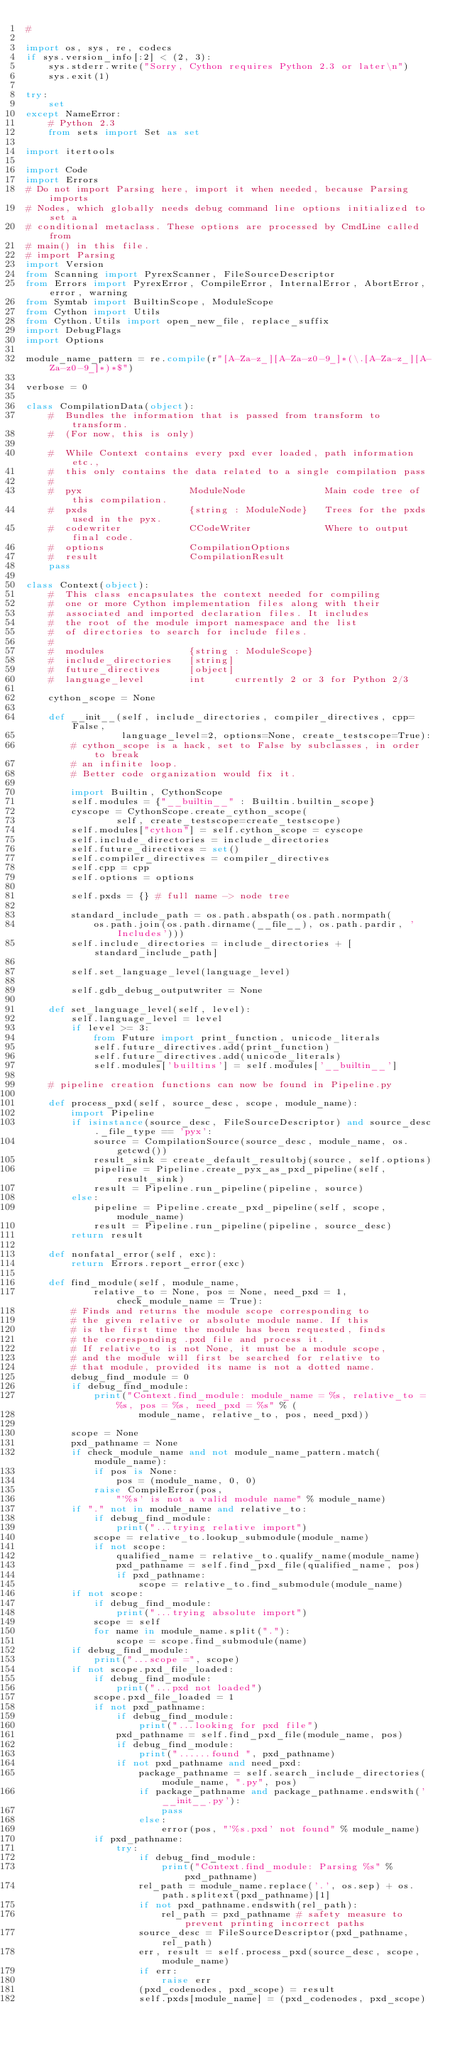<code> <loc_0><loc_0><loc_500><loc_500><_Python_>#

import os, sys, re, codecs
if sys.version_info[:2] < (2, 3):
    sys.stderr.write("Sorry, Cython requires Python 2.3 or later\n")
    sys.exit(1)

try:
    set
except NameError:
    # Python 2.3
    from sets import Set as set

import itertools

import Code
import Errors
# Do not import Parsing here, import it when needed, because Parsing imports
# Nodes, which globally needs debug command line options initialized to set a
# conditional metaclass. These options are processed by CmdLine called from
# main() in this file.
# import Parsing
import Version
from Scanning import PyrexScanner, FileSourceDescriptor
from Errors import PyrexError, CompileError, InternalError, AbortError, error, warning
from Symtab import BuiltinScope, ModuleScope
from Cython import Utils
from Cython.Utils import open_new_file, replace_suffix
import DebugFlags
import Options

module_name_pattern = re.compile(r"[A-Za-z_][A-Za-z0-9_]*(\.[A-Za-z_][A-Za-z0-9_]*)*$")

verbose = 0

class CompilationData(object):
    #  Bundles the information that is passed from transform to transform.
    #  (For now, this is only)

    #  While Context contains every pxd ever loaded, path information etc.,
    #  this only contains the data related to a single compilation pass
    #
    #  pyx                   ModuleNode              Main code tree of this compilation.
    #  pxds                  {string : ModuleNode}   Trees for the pxds used in the pyx.
    #  codewriter            CCodeWriter             Where to output final code.
    #  options               CompilationOptions
    #  result                CompilationResult
    pass

class Context(object):
    #  This class encapsulates the context needed for compiling
    #  one or more Cython implementation files along with their
    #  associated and imported declaration files. It includes
    #  the root of the module import namespace and the list
    #  of directories to search for include files.
    #
    #  modules               {string : ModuleScope}
    #  include_directories   [string]
    #  future_directives     [object]
    #  language_level        int     currently 2 or 3 for Python 2/3

    cython_scope = None

    def __init__(self, include_directories, compiler_directives, cpp=False,
                 language_level=2, options=None, create_testscope=True):
        # cython_scope is a hack, set to False by subclasses, in order to break
        # an infinite loop.
        # Better code organization would fix it.

        import Builtin, CythonScope
        self.modules = {"__builtin__" : Builtin.builtin_scope}
        cyscope = CythonScope.create_cython_scope(
                self, create_testscope=create_testscope)
        self.modules["cython"] = self.cython_scope = cyscope
        self.include_directories = include_directories
        self.future_directives = set()
        self.compiler_directives = compiler_directives
        self.cpp = cpp
        self.options = options

        self.pxds = {} # full name -> node tree

        standard_include_path = os.path.abspath(os.path.normpath(
            os.path.join(os.path.dirname(__file__), os.path.pardir, 'Includes')))
        self.include_directories = include_directories + [standard_include_path]

        self.set_language_level(language_level)

        self.gdb_debug_outputwriter = None

    def set_language_level(self, level):
        self.language_level = level
        if level >= 3:
            from Future import print_function, unicode_literals
            self.future_directives.add(print_function)
            self.future_directives.add(unicode_literals)
            self.modules['builtins'] = self.modules['__builtin__']

    # pipeline creation functions can now be found in Pipeline.py

    def process_pxd(self, source_desc, scope, module_name):
        import Pipeline
        if isinstance(source_desc, FileSourceDescriptor) and source_desc._file_type == 'pyx':
            source = CompilationSource(source_desc, module_name, os.getcwd())
            result_sink = create_default_resultobj(source, self.options)
            pipeline = Pipeline.create_pyx_as_pxd_pipeline(self, result_sink)
            result = Pipeline.run_pipeline(pipeline, source)
        else:
            pipeline = Pipeline.create_pxd_pipeline(self, scope, module_name)
            result = Pipeline.run_pipeline(pipeline, source_desc)
        return result

    def nonfatal_error(self, exc):
        return Errors.report_error(exc)

    def find_module(self, module_name,
            relative_to = None, pos = None, need_pxd = 1, check_module_name = True):
        # Finds and returns the module scope corresponding to
        # the given relative or absolute module name. If this
        # is the first time the module has been requested, finds
        # the corresponding .pxd file and process it.
        # If relative_to is not None, it must be a module scope,
        # and the module will first be searched for relative to
        # that module, provided its name is not a dotted name.
        debug_find_module = 0
        if debug_find_module:
            print("Context.find_module: module_name = %s, relative_to = %s, pos = %s, need_pxd = %s" % (
                    module_name, relative_to, pos, need_pxd))

        scope = None
        pxd_pathname = None
        if check_module_name and not module_name_pattern.match(module_name):
            if pos is None:
                pos = (module_name, 0, 0)
            raise CompileError(pos,
                "'%s' is not a valid module name" % module_name)
        if "." not in module_name and relative_to:
            if debug_find_module:
                print("...trying relative import")
            scope = relative_to.lookup_submodule(module_name)
            if not scope:
                qualified_name = relative_to.qualify_name(module_name)
                pxd_pathname = self.find_pxd_file(qualified_name, pos)
                if pxd_pathname:
                    scope = relative_to.find_submodule(module_name)
        if not scope:
            if debug_find_module:
                print("...trying absolute import")
            scope = self
            for name in module_name.split("."):
                scope = scope.find_submodule(name)
        if debug_find_module:
            print("...scope =", scope)
        if not scope.pxd_file_loaded:
            if debug_find_module:
                print("...pxd not loaded")
            scope.pxd_file_loaded = 1
            if not pxd_pathname:
                if debug_find_module:
                    print("...looking for pxd file")
                pxd_pathname = self.find_pxd_file(module_name, pos)
                if debug_find_module:
                    print("......found ", pxd_pathname)
                if not pxd_pathname and need_pxd:
                    package_pathname = self.search_include_directories(module_name, ".py", pos)
                    if package_pathname and package_pathname.endswith('__init__.py'):
                        pass
                    else:
                        error(pos, "'%s.pxd' not found" % module_name)
            if pxd_pathname:
                try:
                    if debug_find_module:
                        print("Context.find_module: Parsing %s" % pxd_pathname)
                    rel_path = module_name.replace('.', os.sep) + os.path.splitext(pxd_pathname)[1]
                    if not pxd_pathname.endswith(rel_path):
                        rel_path = pxd_pathname # safety measure to prevent printing incorrect paths
                    source_desc = FileSourceDescriptor(pxd_pathname, rel_path)
                    err, result = self.process_pxd(source_desc, scope, module_name)
                    if err:
                        raise err
                    (pxd_codenodes, pxd_scope) = result
                    self.pxds[module_name] = (pxd_codenodes, pxd_scope)</code> 